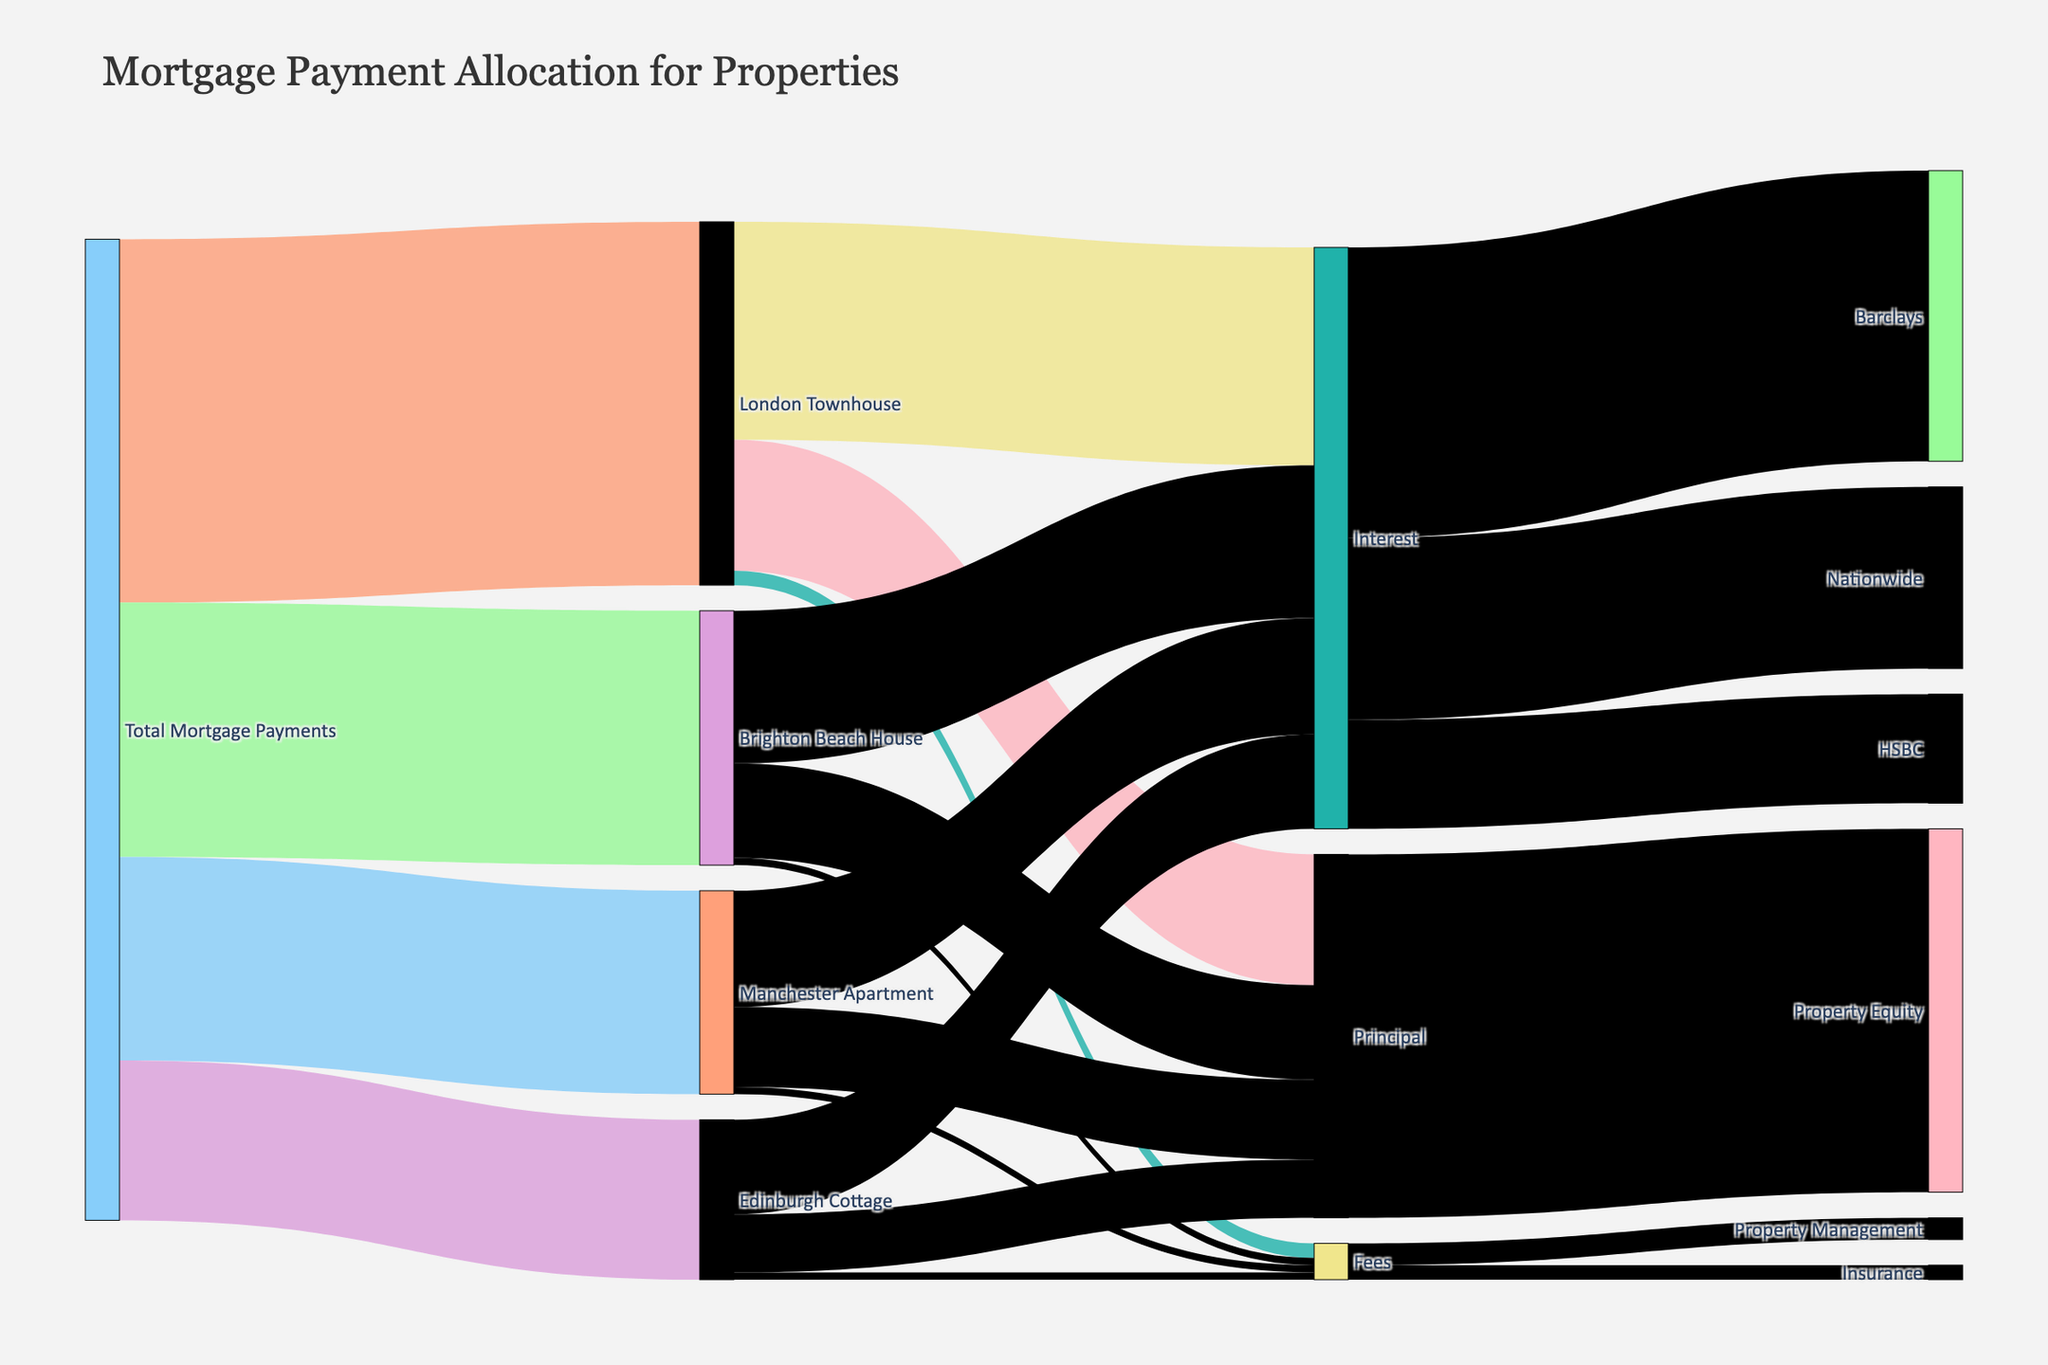What's the title of the figure? The title is usually displayed prominently at the top of the figure. In this case, it is "Mortgage Payment Allocation for Properties".
Answer: Mortgage Payment Allocation for Properties Which property has the highest total mortgage payments? To find this, look for the property with the largest value flowing from "Total Mortgage Payments". The London Townhouse has 5000, which is the highest.
Answer: London Townhouse What are the three main components of the mortgage payments for each property? By examining the connections from each property, we see that the payments are divided into Interest, Principal, and Fees.
Answer: Interest, Principal, Fees How much of the mortgage payments for the Brighton Beach House goes toward fees? Look for the flow from "Brighton Beach House" to "Fees". The value is 100.
Answer: 100 Compare the total interest payments for the London Townhouse and the Manchester Apartment. Which is higher, and by how much? London Townhouse to Interest is 3000, Manchester Apartment to Interest is 1600. The difference is 3000 - 1600 = 1400.
Answer: London Townhouse, 1400 How much total interest is paid across all properties? Sum up the interest values from all properties: 3000 (London Townhouse) + 2100 (Brighton Beach House) + 1600 (Manchester Apartment) + 1300 (Edinburgh Cottage) = 8000.
Answer: 8000 Which lender receives the highest amount of interest? Check the flows from "Interest" to the lenders. Barclays receives 4000, Nationwide 2500, and HSBC 1500. Barclays is the highest.
Answer: Barclays How much of the total principal is directed towards property equity? Follow the flow from "Principal" to its target. It shows a single flow of 5000 towards Property Equity.
Answer: 5000 What is the combined value of fees paid for property management and insurance? Add the values for fees: 300 (Property Management) + 200 (Insurance) = 500.
Answer: 500 If we consolidate all mortgage payments towards the Edinburgh Cottage, what is the total value, and how is it distributed? The total mortgage payment value is 2200. The distribution is: Interest (1300), Principal (800), Fees (100). Adding these up: 1300 + 800 + 100 = 2200.
Answer: 2200, 1300 Interest, 800 Principal, 100 Fees 